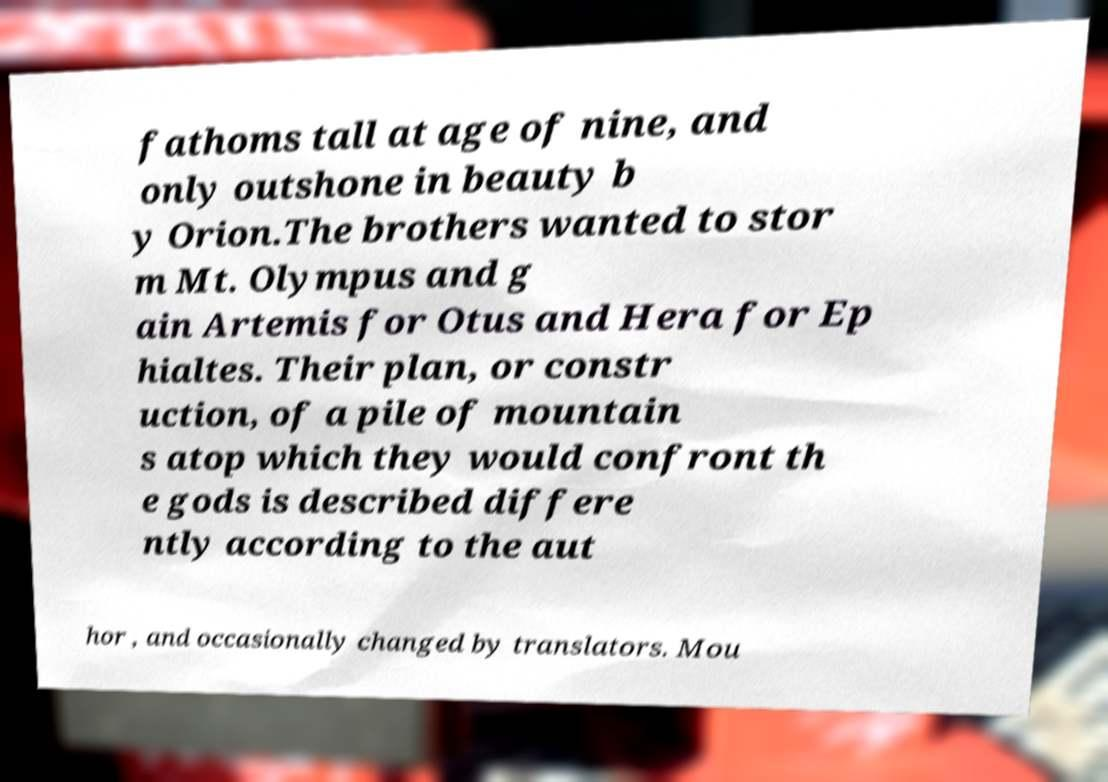Can you accurately transcribe the text from the provided image for me? fathoms tall at age of nine, and only outshone in beauty b y Orion.The brothers wanted to stor m Mt. Olympus and g ain Artemis for Otus and Hera for Ep hialtes. Their plan, or constr uction, of a pile of mountain s atop which they would confront th e gods is described differe ntly according to the aut hor , and occasionally changed by translators. Mou 